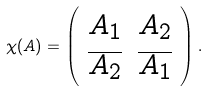Convert formula to latex. <formula><loc_0><loc_0><loc_500><loc_500>\chi ( A ) = \left ( \begin{array} { c c } A _ { 1 } & A _ { 2 } \\ \overline { A _ { 2 } } & \overline { A _ { 1 } } \\ \end{array} \right ) .</formula> 